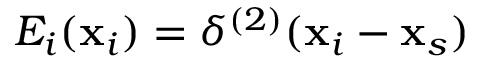Convert formula to latex. <formula><loc_0><loc_0><loc_500><loc_500>E _ { i } ( x _ { i } ) = \delta ^ { ( 2 ) } ( x _ { i } - x _ { s } )</formula> 